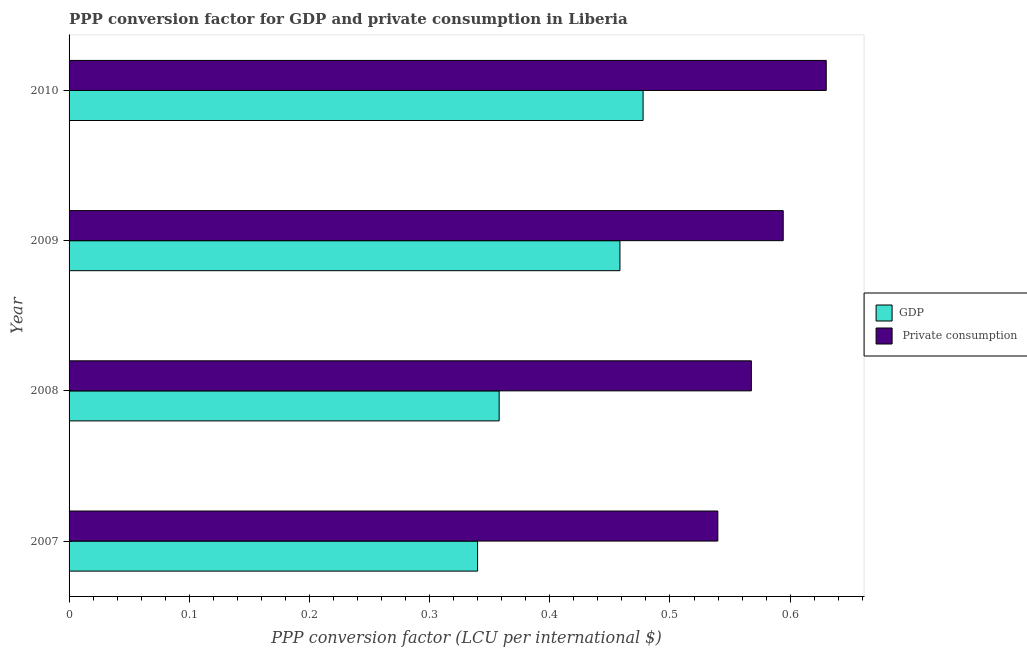How many different coloured bars are there?
Offer a terse response. 2. How many bars are there on the 3rd tick from the bottom?
Offer a terse response. 2. In how many cases, is the number of bars for a given year not equal to the number of legend labels?
Your response must be concise. 0. What is the ppp conversion factor for private consumption in 2010?
Offer a terse response. 0.63. Across all years, what is the maximum ppp conversion factor for private consumption?
Provide a short and direct response. 0.63. Across all years, what is the minimum ppp conversion factor for private consumption?
Offer a terse response. 0.54. In which year was the ppp conversion factor for gdp maximum?
Provide a succinct answer. 2010. In which year was the ppp conversion factor for gdp minimum?
Offer a terse response. 2007. What is the total ppp conversion factor for private consumption in the graph?
Ensure brevity in your answer.  2.33. What is the difference between the ppp conversion factor for gdp in 2008 and that in 2010?
Provide a succinct answer. -0.12. What is the difference between the ppp conversion factor for private consumption in 2009 and the ppp conversion factor for gdp in 2010?
Your answer should be compact. 0.12. What is the average ppp conversion factor for private consumption per year?
Offer a very short reply. 0.58. In the year 2010, what is the difference between the ppp conversion factor for gdp and ppp conversion factor for private consumption?
Keep it short and to the point. -0.15. In how many years, is the ppp conversion factor for private consumption greater than 0.36000000000000004 LCU?
Give a very brief answer. 4. What is the ratio of the ppp conversion factor for private consumption in 2007 to that in 2010?
Give a very brief answer. 0.86. Is the ppp conversion factor for private consumption in 2007 less than that in 2010?
Provide a succinct answer. Yes. What is the difference between the highest and the second highest ppp conversion factor for gdp?
Ensure brevity in your answer.  0.02. What is the difference between the highest and the lowest ppp conversion factor for gdp?
Keep it short and to the point. 0.14. In how many years, is the ppp conversion factor for gdp greater than the average ppp conversion factor for gdp taken over all years?
Give a very brief answer. 2. What does the 1st bar from the top in 2008 represents?
Give a very brief answer.  Private consumption. What does the 2nd bar from the bottom in 2008 represents?
Make the answer very short.  Private consumption. Are all the bars in the graph horizontal?
Your answer should be very brief. Yes. How many years are there in the graph?
Your response must be concise. 4. What is the difference between two consecutive major ticks on the X-axis?
Your answer should be compact. 0.1. Does the graph contain any zero values?
Keep it short and to the point. No. Does the graph contain grids?
Keep it short and to the point. No. Where does the legend appear in the graph?
Provide a succinct answer. Center right. How are the legend labels stacked?
Keep it short and to the point. Vertical. What is the title of the graph?
Provide a succinct answer. PPP conversion factor for GDP and private consumption in Liberia. Does "Enforce a contract" appear as one of the legend labels in the graph?
Offer a very short reply. No. What is the label or title of the X-axis?
Your response must be concise. PPP conversion factor (LCU per international $). What is the label or title of the Y-axis?
Give a very brief answer. Year. What is the PPP conversion factor (LCU per international $) of GDP in 2007?
Make the answer very short. 0.34. What is the PPP conversion factor (LCU per international $) of  Private consumption in 2007?
Your answer should be very brief. 0.54. What is the PPP conversion factor (LCU per international $) of GDP in 2008?
Ensure brevity in your answer.  0.36. What is the PPP conversion factor (LCU per international $) in  Private consumption in 2008?
Make the answer very short. 0.57. What is the PPP conversion factor (LCU per international $) of GDP in 2009?
Your answer should be very brief. 0.46. What is the PPP conversion factor (LCU per international $) of  Private consumption in 2009?
Your response must be concise. 0.59. What is the PPP conversion factor (LCU per international $) of GDP in 2010?
Ensure brevity in your answer.  0.48. What is the PPP conversion factor (LCU per international $) in  Private consumption in 2010?
Give a very brief answer. 0.63. Across all years, what is the maximum PPP conversion factor (LCU per international $) of GDP?
Your answer should be compact. 0.48. Across all years, what is the maximum PPP conversion factor (LCU per international $) of  Private consumption?
Offer a terse response. 0.63. Across all years, what is the minimum PPP conversion factor (LCU per international $) in GDP?
Provide a succinct answer. 0.34. Across all years, what is the minimum PPP conversion factor (LCU per international $) of  Private consumption?
Offer a terse response. 0.54. What is the total PPP conversion factor (LCU per international $) in GDP in the graph?
Ensure brevity in your answer.  1.63. What is the total PPP conversion factor (LCU per international $) of  Private consumption in the graph?
Provide a succinct answer. 2.33. What is the difference between the PPP conversion factor (LCU per international $) in GDP in 2007 and that in 2008?
Your response must be concise. -0.02. What is the difference between the PPP conversion factor (LCU per international $) of  Private consumption in 2007 and that in 2008?
Provide a succinct answer. -0.03. What is the difference between the PPP conversion factor (LCU per international $) in GDP in 2007 and that in 2009?
Ensure brevity in your answer.  -0.12. What is the difference between the PPP conversion factor (LCU per international $) of  Private consumption in 2007 and that in 2009?
Your answer should be compact. -0.05. What is the difference between the PPP conversion factor (LCU per international $) in GDP in 2007 and that in 2010?
Provide a succinct answer. -0.14. What is the difference between the PPP conversion factor (LCU per international $) in  Private consumption in 2007 and that in 2010?
Ensure brevity in your answer.  -0.09. What is the difference between the PPP conversion factor (LCU per international $) in GDP in 2008 and that in 2009?
Offer a very short reply. -0.1. What is the difference between the PPP conversion factor (LCU per international $) of  Private consumption in 2008 and that in 2009?
Provide a short and direct response. -0.03. What is the difference between the PPP conversion factor (LCU per international $) in GDP in 2008 and that in 2010?
Offer a terse response. -0.12. What is the difference between the PPP conversion factor (LCU per international $) of  Private consumption in 2008 and that in 2010?
Ensure brevity in your answer.  -0.06. What is the difference between the PPP conversion factor (LCU per international $) of GDP in 2009 and that in 2010?
Give a very brief answer. -0.02. What is the difference between the PPP conversion factor (LCU per international $) of  Private consumption in 2009 and that in 2010?
Provide a short and direct response. -0.04. What is the difference between the PPP conversion factor (LCU per international $) of GDP in 2007 and the PPP conversion factor (LCU per international $) of  Private consumption in 2008?
Provide a succinct answer. -0.23. What is the difference between the PPP conversion factor (LCU per international $) in GDP in 2007 and the PPP conversion factor (LCU per international $) in  Private consumption in 2009?
Offer a very short reply. -0.25. What is the difference between the PPP conversion factor (LCU per international $) in GDP in 2007 and the PPP conversion factor (LCU per international $) in  Private consumption in 2010?
Provide a succinct answer. -0.29. What is the difference between the PPP conversion factor (LCU per international $) in GDP in 2008 and the PPP conversion factor (LCU per international $) in  Private consumption in 2009?
Provide a succinct answer. -0.24. What is the difference between the PPP conversion factor (LCU per international $) of GDP in 2008 and the PPP conversion factor (LCU per international $) of  Private consumption in 2010?
Provide a short and direct response. -0.27. What is the difference between the PPP conversion factor (LCU per international $) of GDP in 2009 and the PPP conversion factor (LCU per international $) of  Private consumption in 2010?
Provide a short and direct response. -0.17. What is the average PPP conversion factor (LCU per international $) of GDP per year?
Offer a terse response. 0.41. What is the average PPP conversion factor (LCU per international $) in  Private consumption per year?
Give a very brief answer. 0.58. In the year 2007, what is the difference between the PPP conversion factor (LCU per international $) of GDP and PPP conversion factor (LCU per international $) of  Private consumption?
Give a very brief answer. -0.2. In the year 2008, what is the difference between the PPP conversion factor (LCU per international $) in GDP and PPP conversion factor (LCU per international $) in  Private consumption?
Your answer should be very brief. -0.21. In the year 2009, what is the difference between the PPP conversion factor (LCU per international $) in GDP and PPP conversion factor (LCU per international $) in  Private consumption?
Your response must be concise. -0.14. In the year 2010, what is the difference between the PPP conversion factor (LCU per international $) of GDP and PPP conversion factor (LCU per international $) of  Private consumption?
Your answer should be compact. -0.15. What is the ratio of the PPP conversion factor (LCU per international $) in GDP in 2007 to that in 2008?
Provide a short and direct response. 0.95. What is the ratio of the PPP conversion factor (LCU per international $) of  Private consumption in 2007 to that in 2008?
Your answer should be very brief. 0.95. What is the ratio of the PPP conversion factor (LCU per international $) in GDP in 2007 to that in 2009?
Provide a short and direct response. 0.74. What is the ratio of the PPP conversion factor (LCU per international $) in  Private consumption in 2007 to that in 2009?
Offer a very short reply. 0.91. What is the ratio of the PPP conversion factor (LCU per international $) of GDP in 2007 to that in 2010?
Your answer should be very brief. 0.71. What is the ratio of the PPP conversion factor (LCU per international $) in  Private consumption in 2007 to that in 2010?
Your response must be concise. 0.86. What is the ratio of the PPP conversion factor (LCU per international $) in GDP in 2008 to that in 2009?
Provide a short and direct response. 0.78. What is the ratio of the PPP conversion factor (LCU per international $) of  Private consumption in 2008 to that in 2009?
Offer a terse response. 0.96. What is the ratio of the PPP conversion factor (LCU per international $) of GDP in 2008 to that in 2010?
Your response must be concise. 0.75. What is the ratio of the PPP conversion factor (LCU per international $) of  Private consumption in 2008 to that in 2010?
Ensure brevity in your answer.  0.9. What is the ratio of the PPP conversion factor (LCU per international $) of GDP in 2009 to that in 2010?
Make the answer very short. 0.96. What is the ratio of the PPP conversion factor (LCU per international $) of  Private consumption in 2009 to that in 2010?
Your answer should be compact. 0.94. What is the difference between the highest and the second highest PPP conversion factor (LCU per international $) in GDP?
Ensure brevity in your answer.  0.02. What is the difference between the highest and the second highest PPP conversion factor (LCU per international $) in  Private consumption?
Ensure brevity in your answer.  0.04. What is the difference between the highest and the lowest PPP conversion factor (LCU per international $) of GDP?
Offer a terse response. 0.14. What is the difference between the highest and the lowest PPP conversion factor (LCU per international $) of  Private consumption?
Offer a terse response. 0.09. 